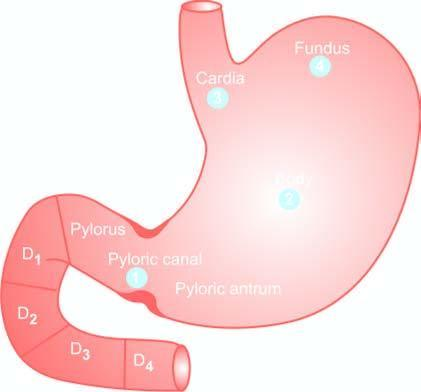does aemosiderin pigment in the cytoplasm of hepatocytes indicate the order of frequency of occurrence of gastric cancer?
Answer the question using a single word or phrase. No 